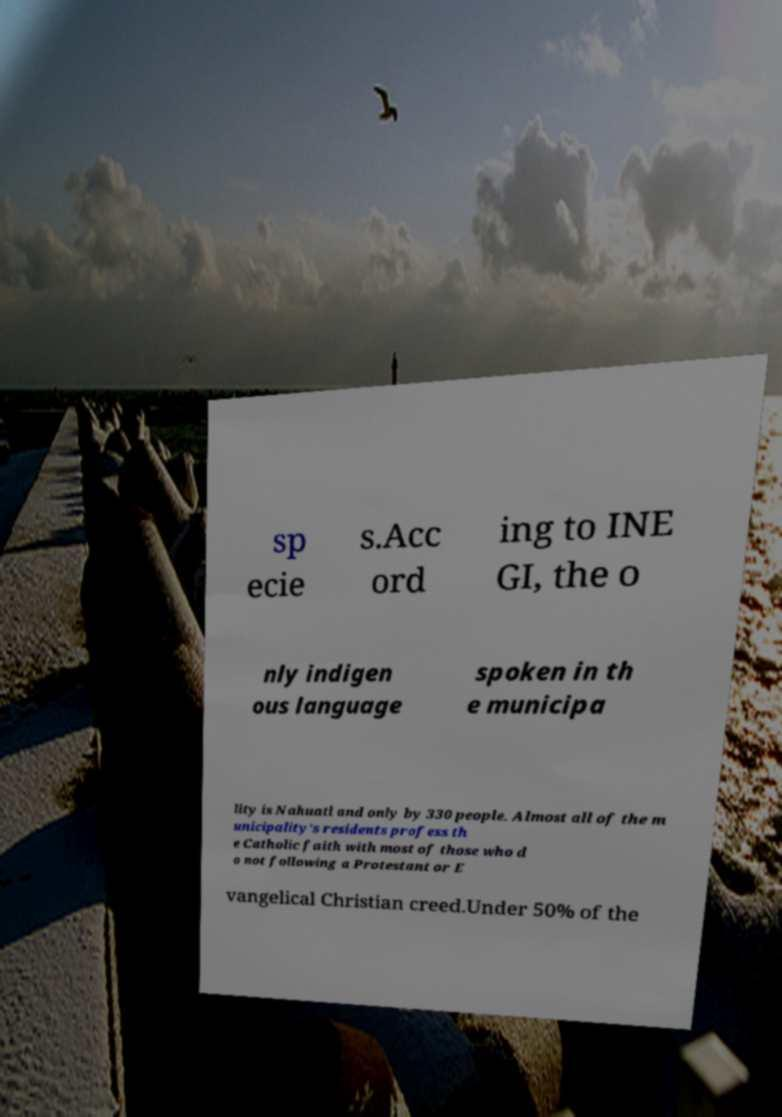There's text embedded in this image that I need extracted. Can you transcribe it verbatim? sp ecie s.Acc ord ing to INE GI, the o nly indigen ous language spoken in th e municipa lity is Nahuatl and only by 330 people. Almost all of the m unicipality's residents profess th e Catholic faith with most of those who d o not following a Protestant or E vangelical Christian creed.Under 50% of the 